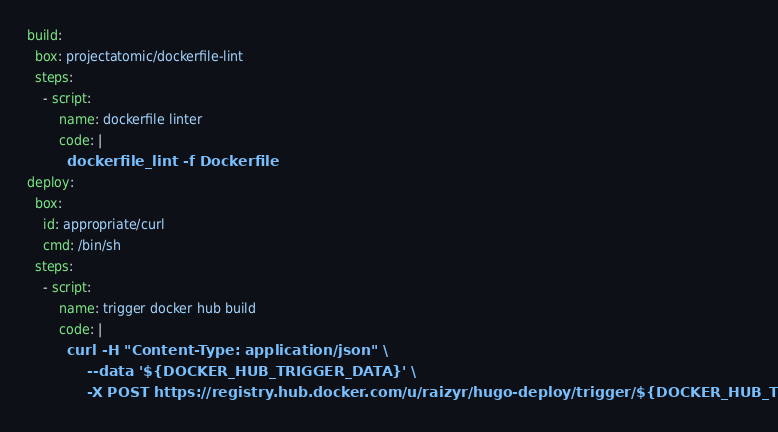Convert code to text. <code><loc_0><loc_0><loc_500><loc_500><_YAML_>build:
  box: projectatomic/dockerfile-lint
  steps:
    - script:
        name: dockerfile linter
        code: |
          dockerfile_lint -f Dockerfile
deploy:
  box: 
    id: appropriate/curl
    cmd: /bin/sh
  steps:
    - script:
        name: trigger docker hub build
        code: |
          curl -H "Content-Type: application/json" \
               --data '${DOCKER_HUB_TRIGGER_DATA}' \
               -X POST https://registry.hub.docker.com/u/raizyr/hugo-deploy/trigger/${DOCKER_HUB_TRIGGER_TOKEN}/
</code> 